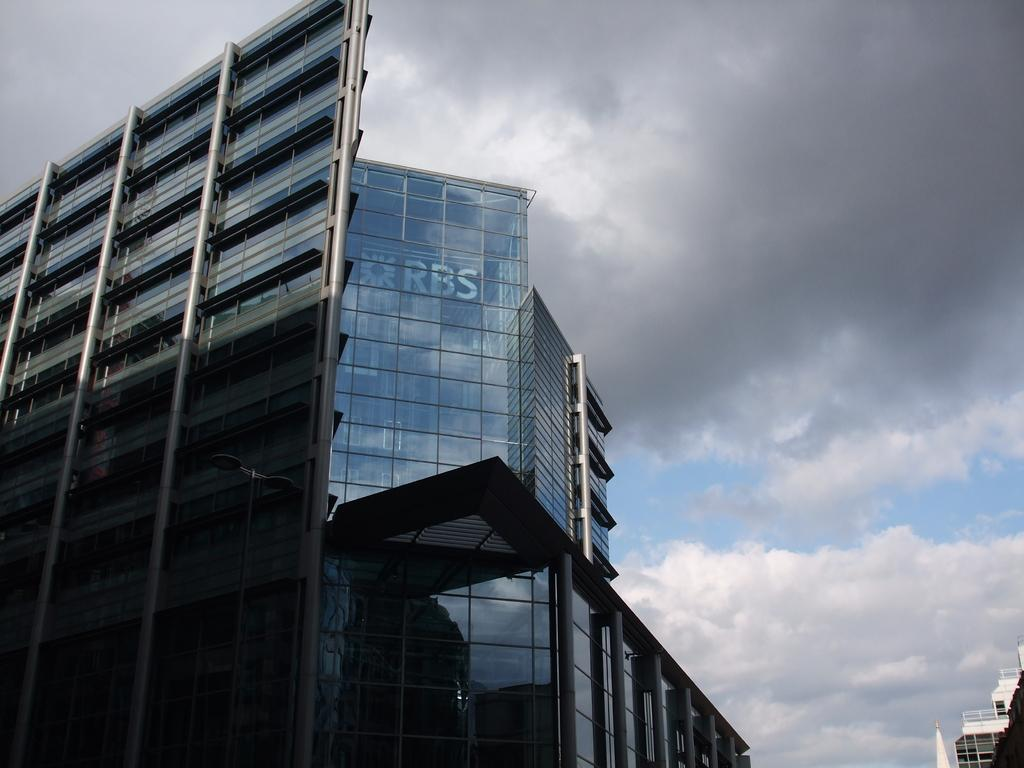What type of structures can be seen in the image? There are buildings in the image. What feature do the buildings have? The buildings have glass windows. How would you describe the sky in the image? The sky is cloudy in the image. Can you read any text in the image? Yes, there is a text visible inside one of the buildings. How does the pollution affect the hill in the image? There is no hill or pollution present in the image. 